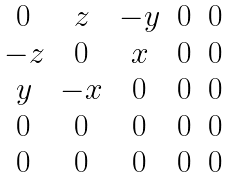<formula> <loc_0><loc_0><loc_500><loc_500>\begin{matrix} 0 & z & - y & 0 & 0 \\ - z & 0 & x & 0 & 0 \\ y & - x & 0 & 0 & 0 \\ 0 & 0 & 0 & 0 & 0 \\ 0 & 0 & 0 & 0 & 0 \end{matrix}</formula> 